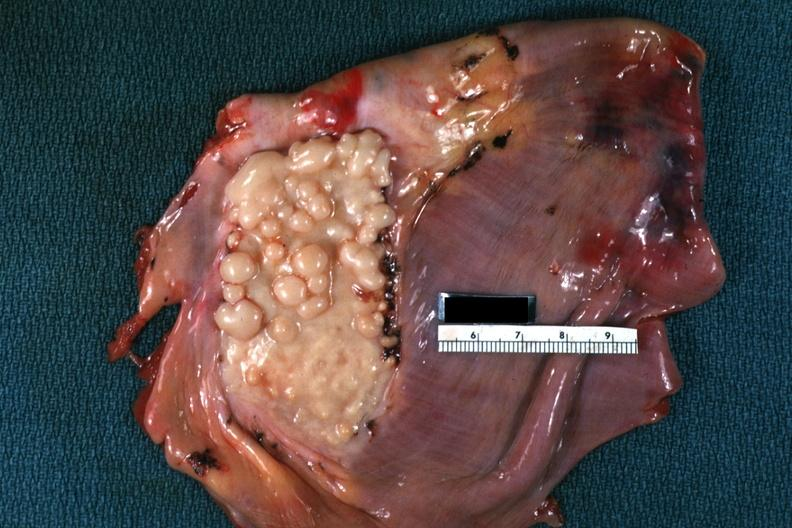what is present?
Answer the question using a single word or phrase. Muscle 